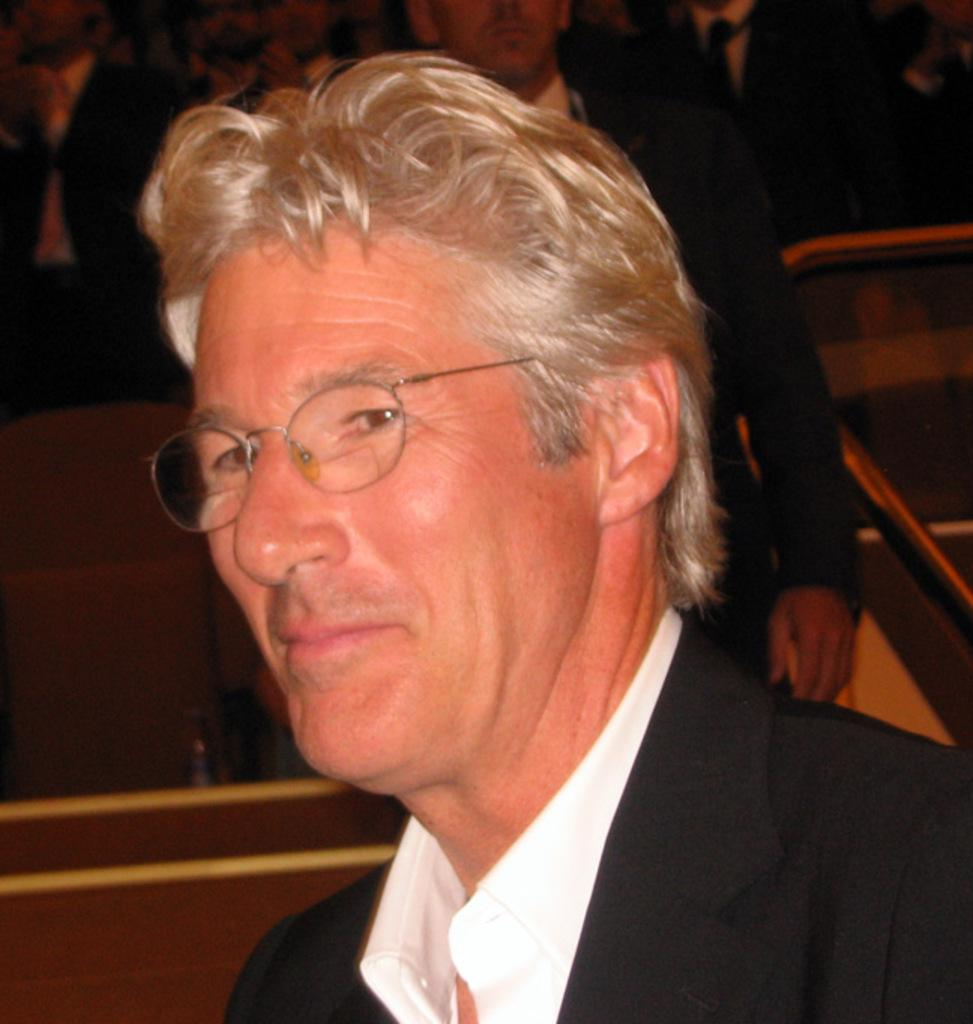What is the main subject of the image? The main subject of the image is a group of people. Can you describe the man in the middle of the group? The man in the middle of the group is wearing spectacles. What objects can be seen in the image besides the people? There are metal rods visible in the image. What is your mom doing in the image? There is no reference to a mom or any individual person in the image, so it's not possible to answer that question. 